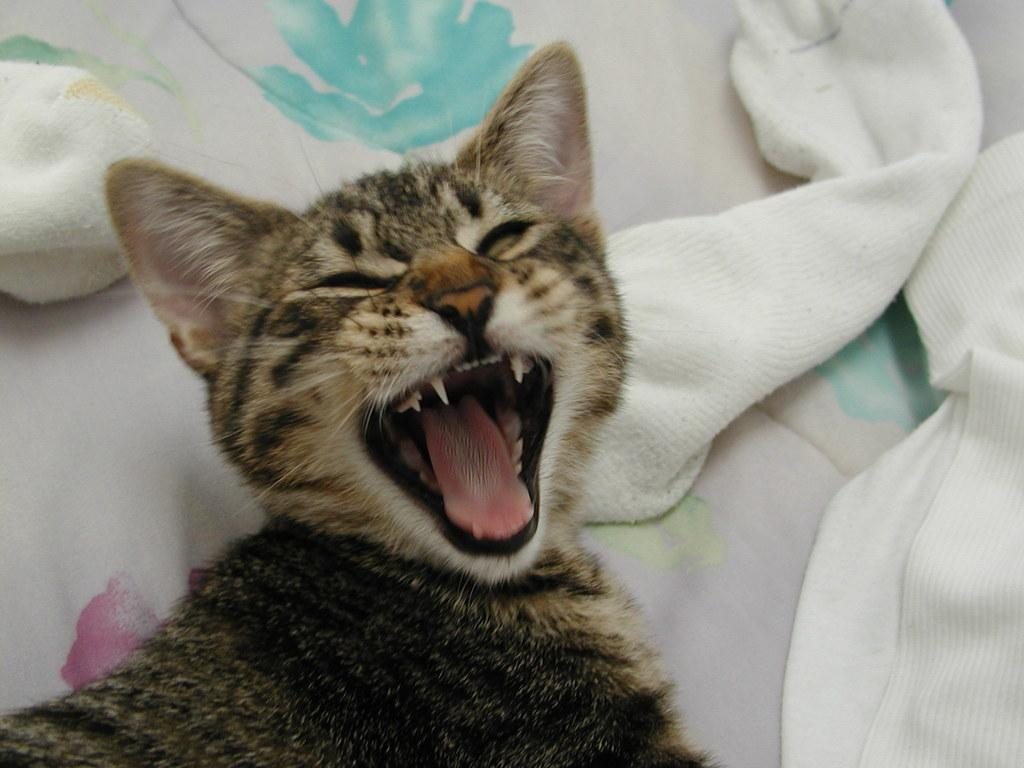What type of animal is in the image? There is a cat in the image. What color is the cat? The cat is brown in color. What is the cat doing in the image? The cat is yawning and sleeping. Where is the cat located in the image? The cat is on a bed. What can be seen in the background of the image? There are pillows in the background of the image. What type of copper material is present in the image? There is no copper material present in the image; it features a brown cat sleeping on a bed with pillows in the background. 